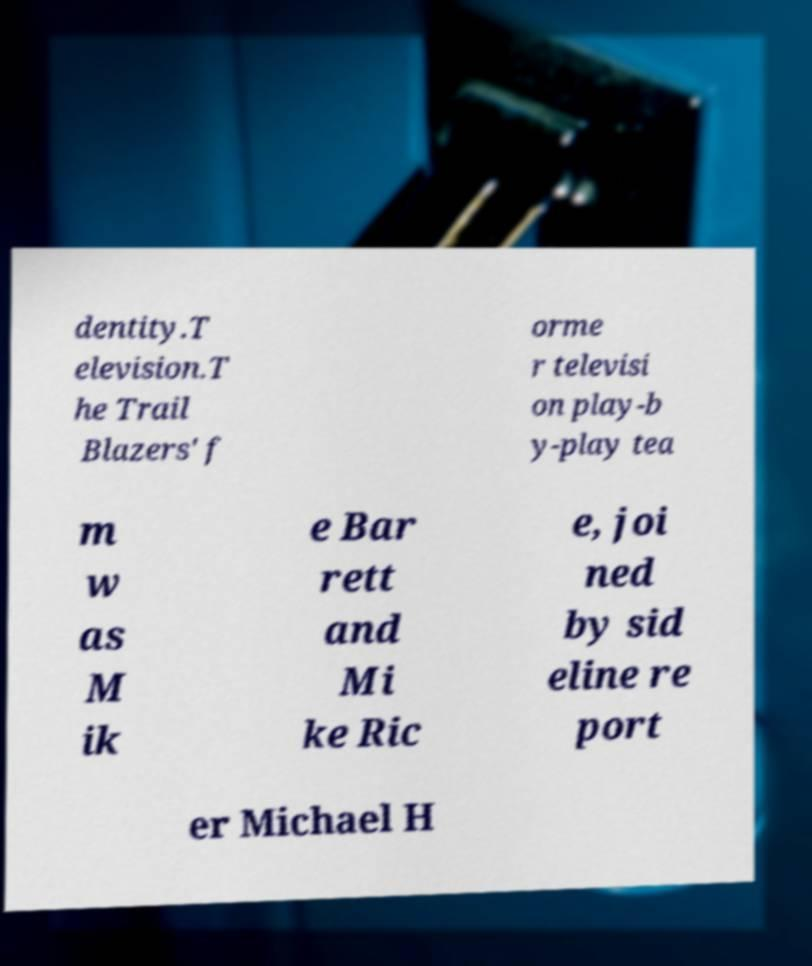Could you extract and type out the text from this image? dentity.T elevision.T he Trail Blazers' f orme r televisi on play-b y-play tea m w as M ik e Bar rett and Mi ke Ric e, joi ned by sid eline re port er Michael H 